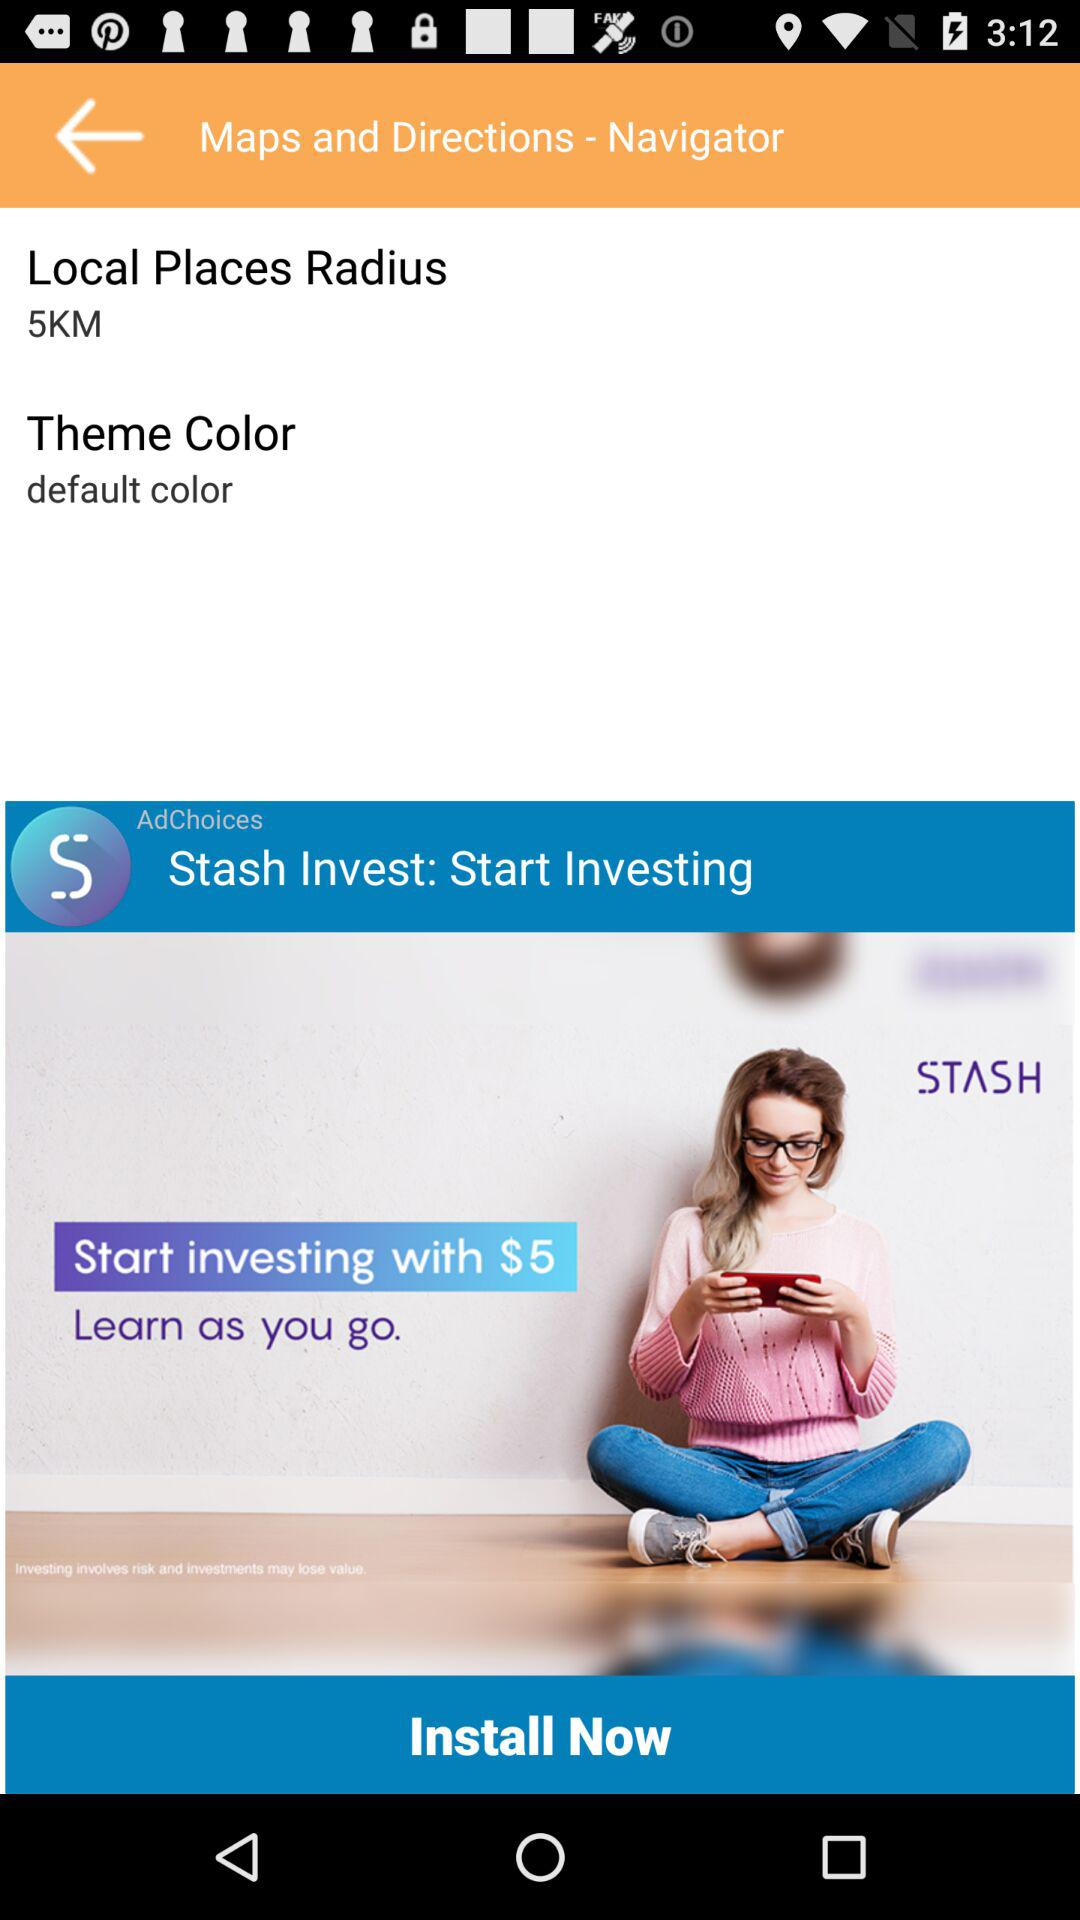What is the theme color? The theme colour is "default". 